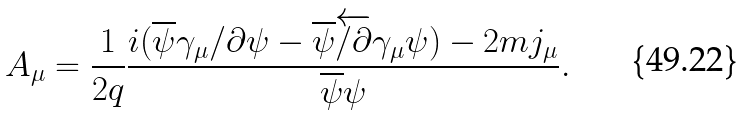<formula> <loc_0><loc_0><loc_500><loc_500>A _ { \mu } = \frac { 1 } { 2 q } \frac { i ( \overline { \psi } \gamma _ { \mu } \slash \partial \psi - \overline { \psi } \overleftarrow { \slash \partial } \gamma _ { \mu } \psi ) - 2 m j _ { \mu } } { \overline { \psi } \psi } .</formula> 